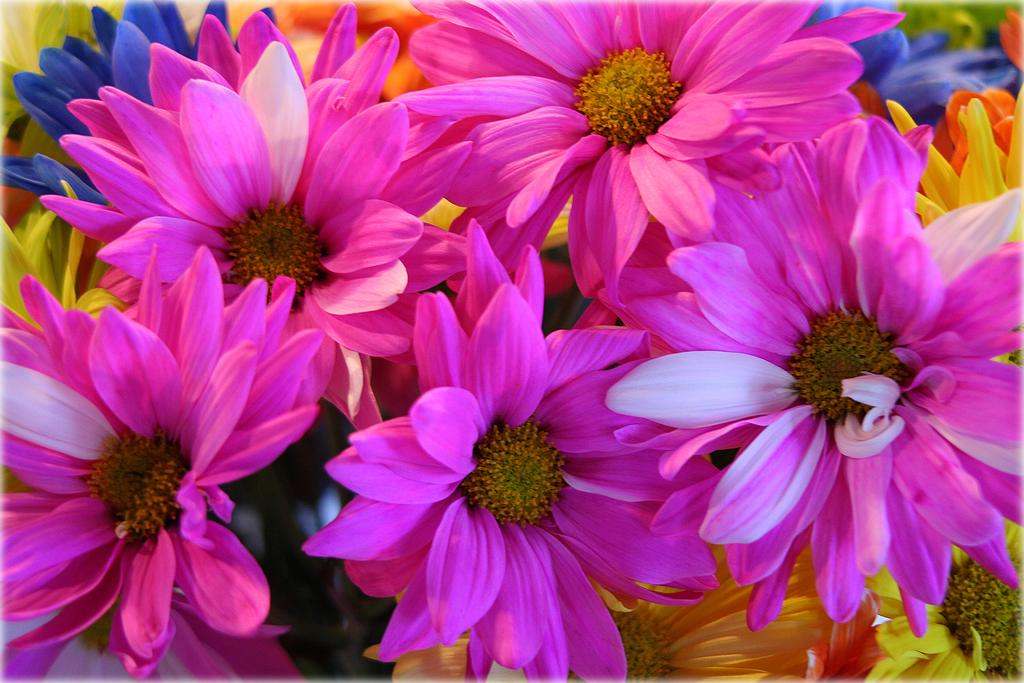What type of living organisms can be seen in the image? Flowers are visible in the image. What type of harmony can be heard in the background of the image? There is no sound or background music present in the image, as it features flowers. 